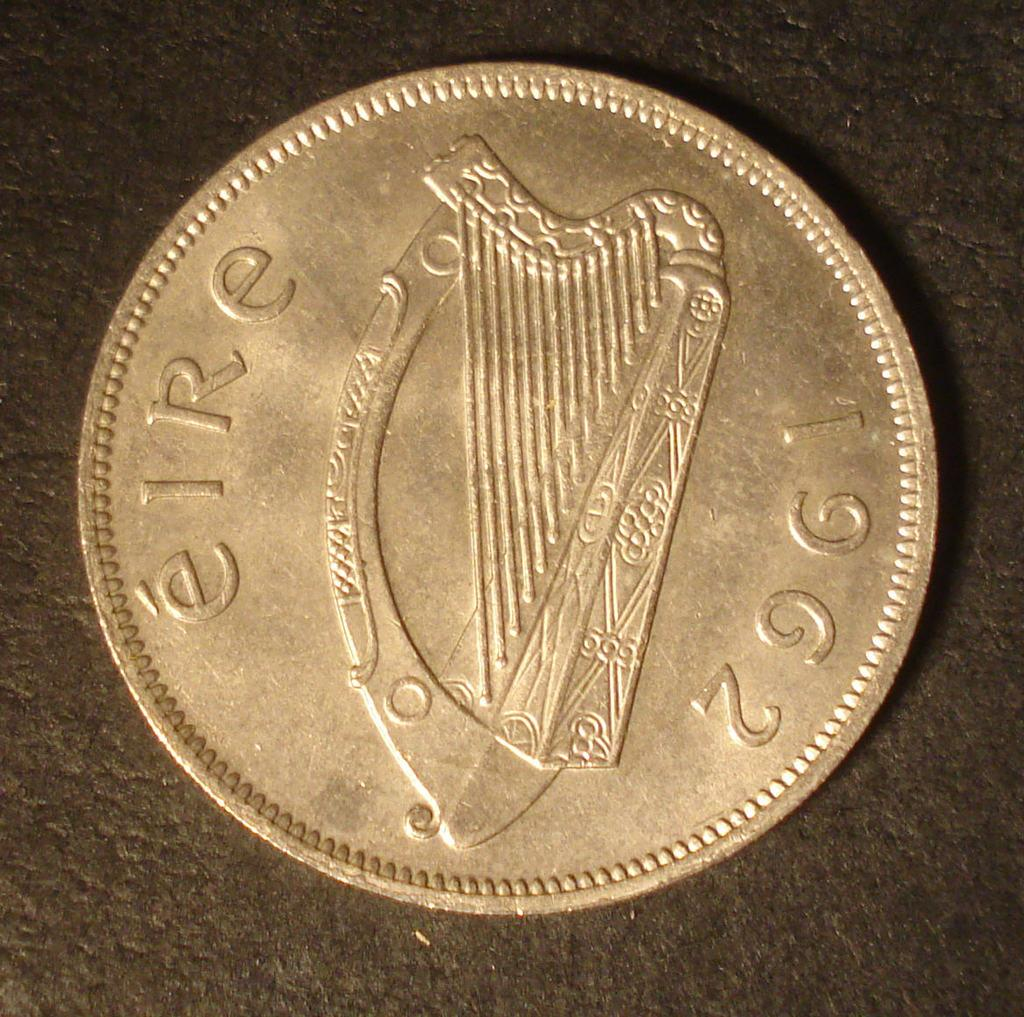<image>
Give a short and clear explanation of the subsequent image. an eire 1962 coin with a harp on it. 